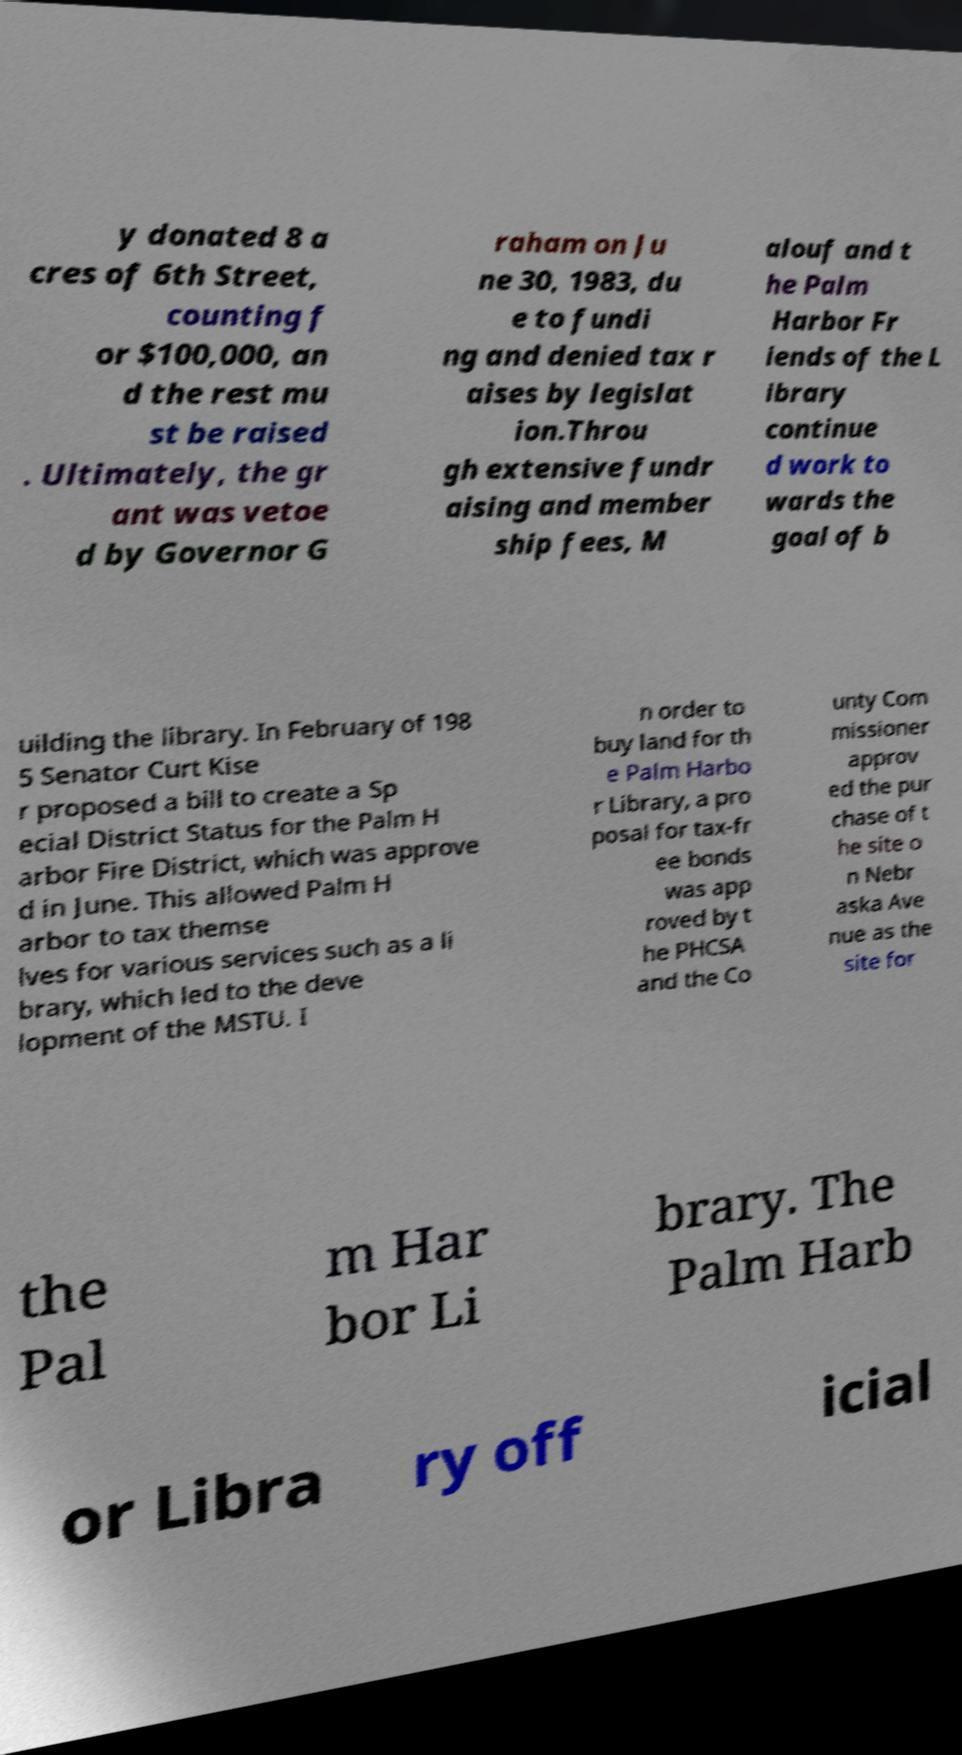Could you assist in decoding the text presented in this image and type it out clearly? y donated 8 a cres of 6th Street, counting f or $100,000, an d the rest mu st be raised . Ultimately, the gr ant was vetoe d by Governor G raham on Ju ne 30, 1983, du e to fundi ng and denied tax r aises by legislat ion.Throu gh extensive fundr aising and member ship fees, M alouf and t he Palm Harbor Fr iends of the L ibrary continue d work to wards the goal of b uilding the library. In February of 198 5 Senator Curt Kise r proposed a bill to create a Sp ecial District Status for the Palm H arbor Fire District, which was approve d in June. This allowed Palm H arbor to tax themse lves for various services such as a li brary, which led to the deve lopment of the MSTU. I n order to buy land for th e Palm Harbo r Library, a pro posal for tax-fr ee bonds was app roved by t he PHCSA and the Co unty Com missioner approv ed the pur chase of t he site o n Nebr aska Ave nue as the site for the Pal m Har bor Li brary. The Palm Harb or Libra ry off icial 